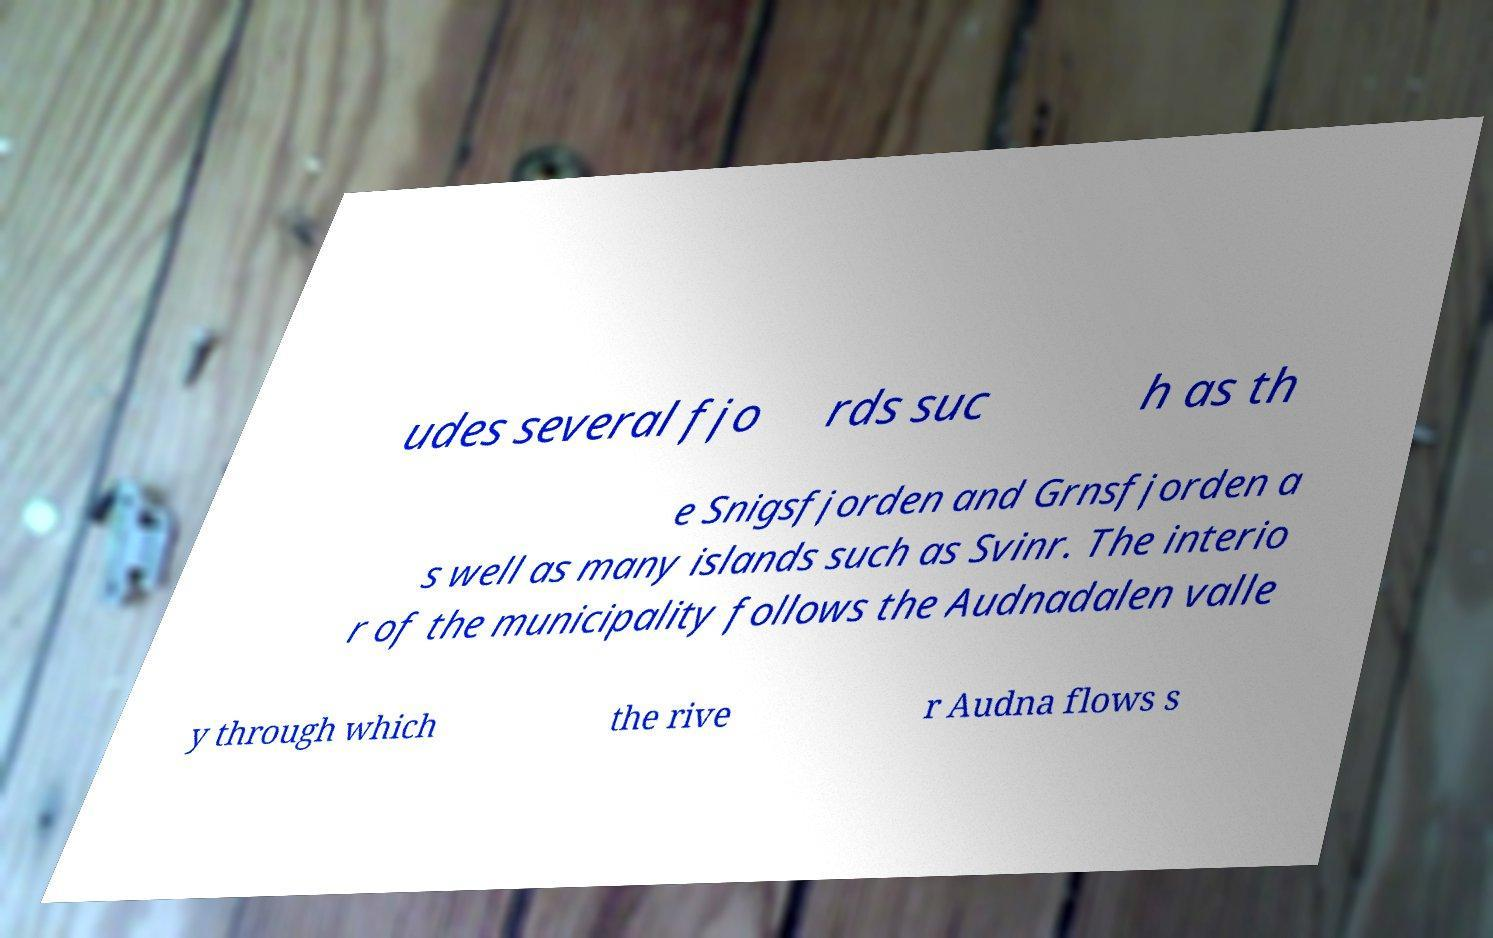Please read and relay the text visible in this image. What does it say? udes several fjo rds suc h as th e Snigsfjorden and Grnsfjorden a s well as many islands such as Svinr. The interio r of the municipality follows the Audnadalen valle y through which the rive r Audna flows s 